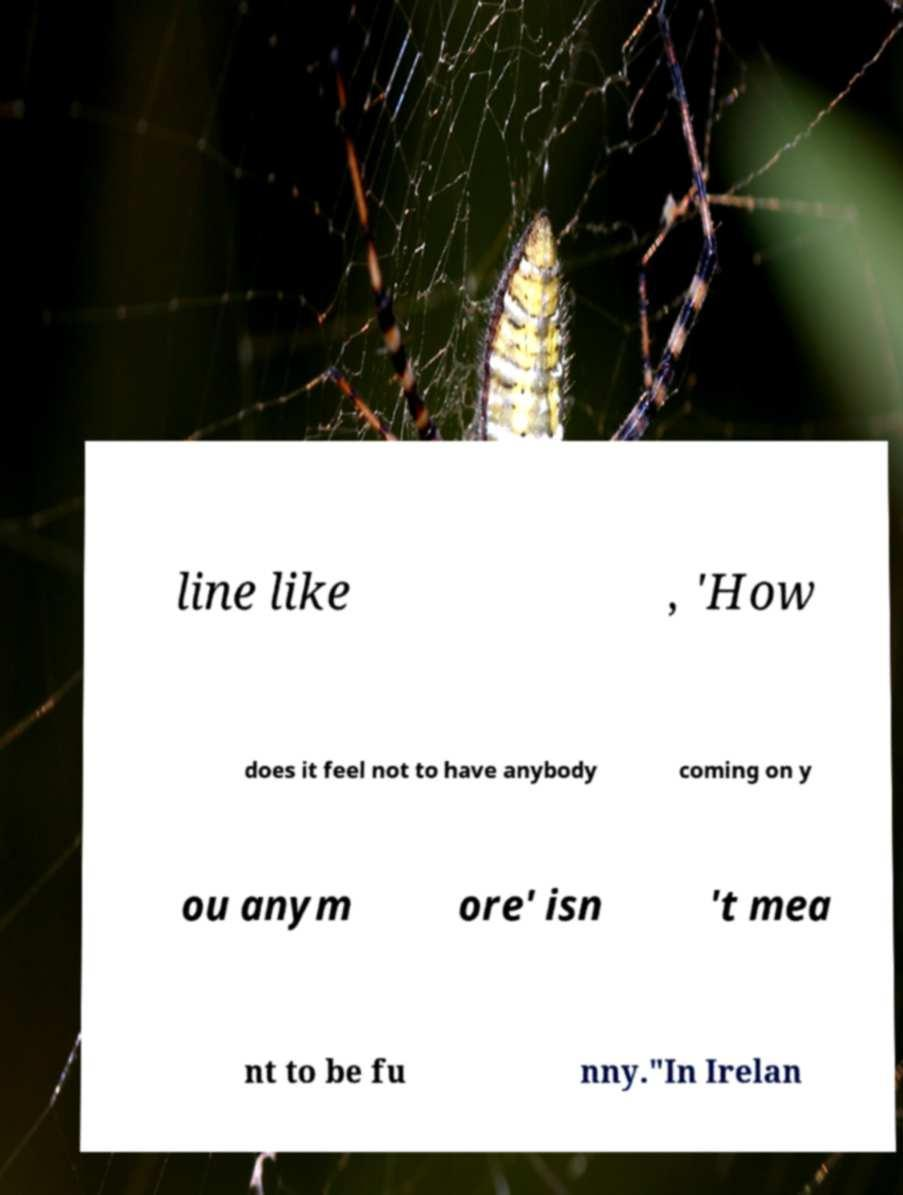I need the written content from this picture converted into text. Can you do that? line like , 'How does it feel not to have anybody coming on y ou anym ore' isn 't mea nt to be fu nny."In Irelan 